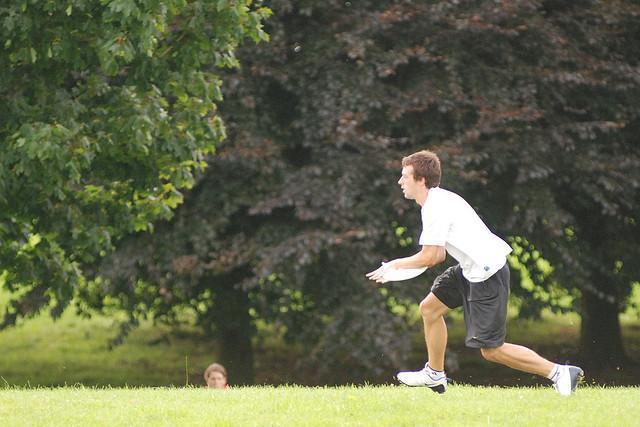How many trees are there?
Give a very brief answer. 3. 